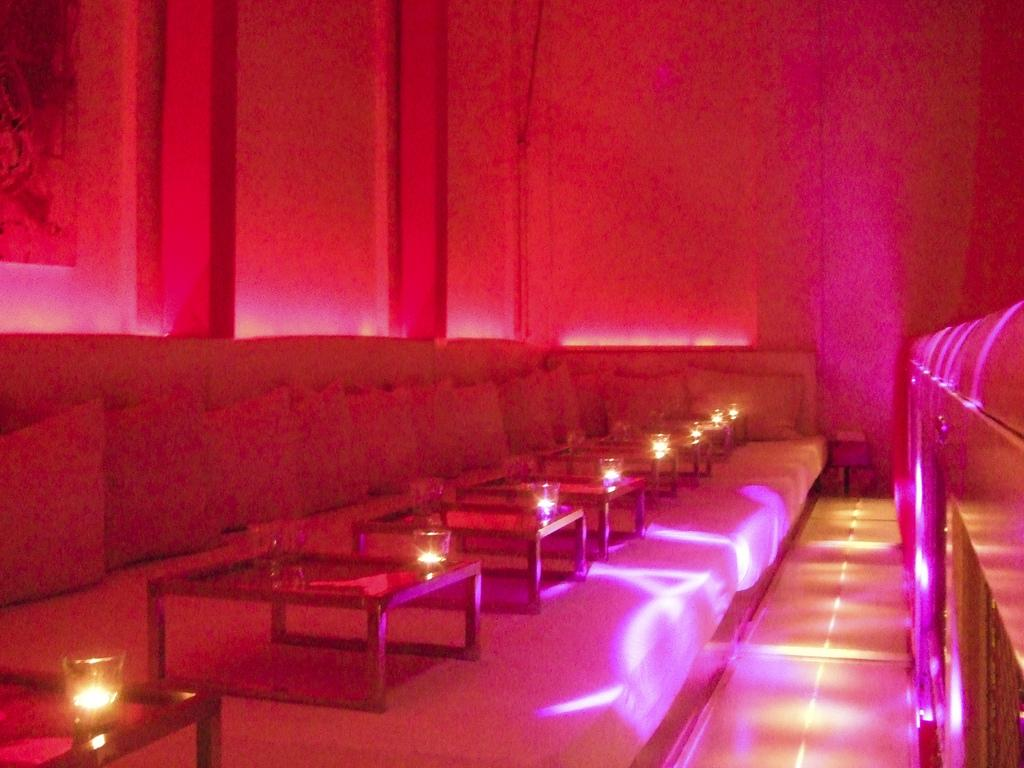What type of furniture is present in the image? There are beds in the image. What is placed on top of the beds? There are tables on the beds. What can be seen on the tables? There are glasses on the tables. What type of cushioning is present on the beds? There are pillows on the beds. How many trains can be seen in the image? There are no trains present in the image. What type of can is visible in the image? There is no can present in the image. 